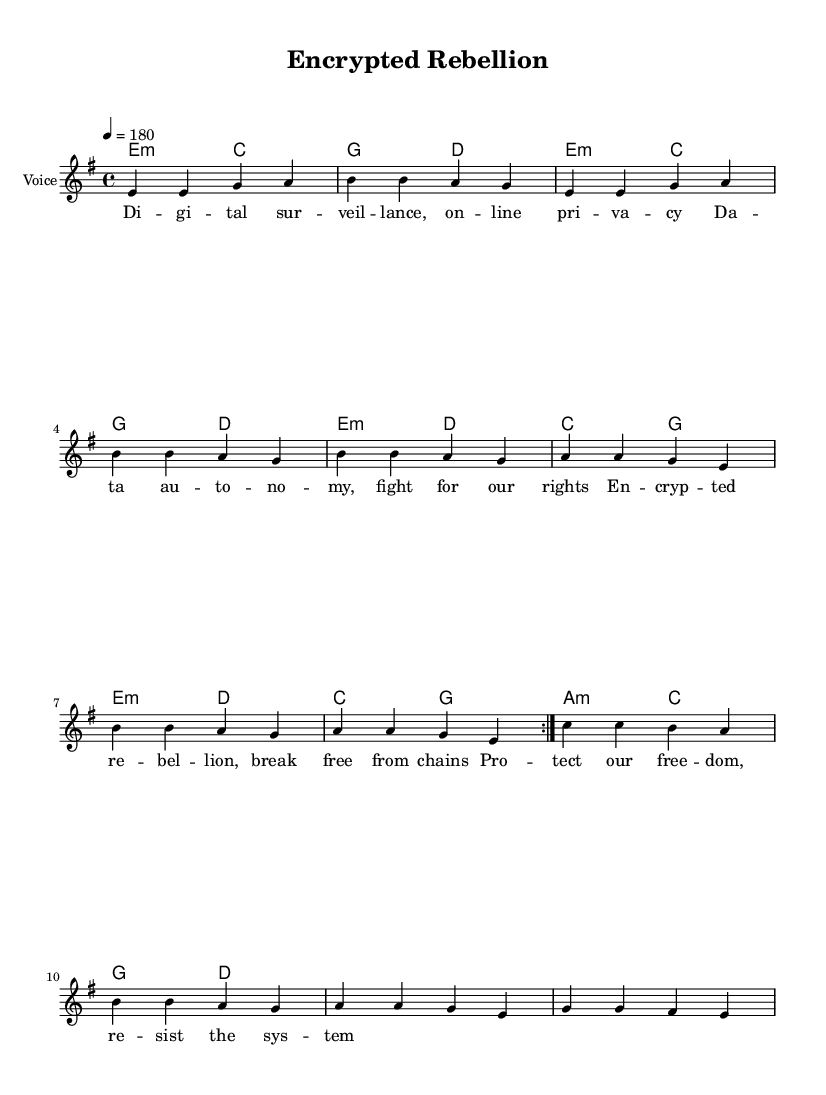What is the key signature of this music? The key signature is indicated by the number of sharps or flats at the beginning of the staff. In this case, there are no sharps or flats, so the key signature is E minor, as indicated by the context of the score.
Answer: E minor What is the time signature of this piece? The time signature is located at the beginning of the piece and is represented by the two numbers stacked one over the other. Here, it shows 4 over 4, meaning there are four beats per measure.
Answer: 4/4 What is the tempo marking for this composition? The tempo marking is usually found under the title and indicates the speed of the piece. The marking here is "4 = 180," which means there are 180 quarter notes per minute.
Answer: 180 How many measures does the melody consist of? To determine the number of measures, one can count the lines or bars of music displayed in the melody. Here, there are 8 measures in total based on the notation shown.
Answer: 8 What is the dynamic of the song based on the phrasing? Dynamics are often indicated by the articulation or text descriptions in the sheet music. In this case, the phrasing suggests an assertive and loud vocal expression. Thus, it implies a strong dynamic typical for punk music.
Answer: Strong What type of chords is primarily used in this piece? The chord symbols provided will indicate the type of chords used, which in this case includes minor chords such as E minor and G major, emphasizing the darker tones typically found in punk music.
Answer: Minor What lyrical theme does this song address? The lyrics directly convey the message of digital privacy, surveillance, and fighting for autonomy. By analyzing the words listed, one can see that the theme is strongly focused on resisting oppression in the digital space.
Answer: Digital privacy 